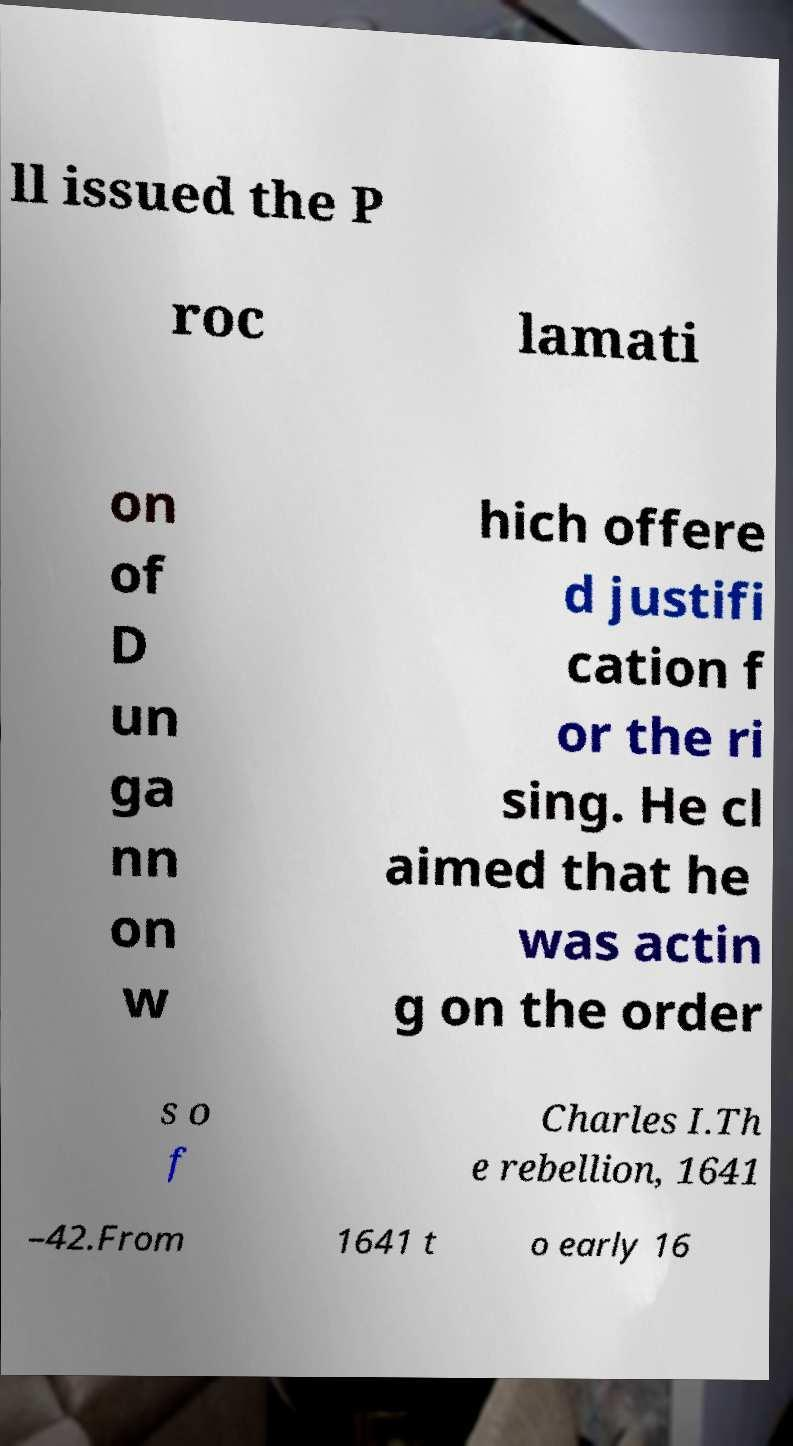Can you accurately transcribe the text from the provided image for me? ll issued the P roc lamati on of D un ga nn on w hich offere d justifi cation f or the ri sing. He cl aimed that he was actin g on the order s o f Charles I.Th e rebellion, 1641 –42.From 1641 t o early 16 